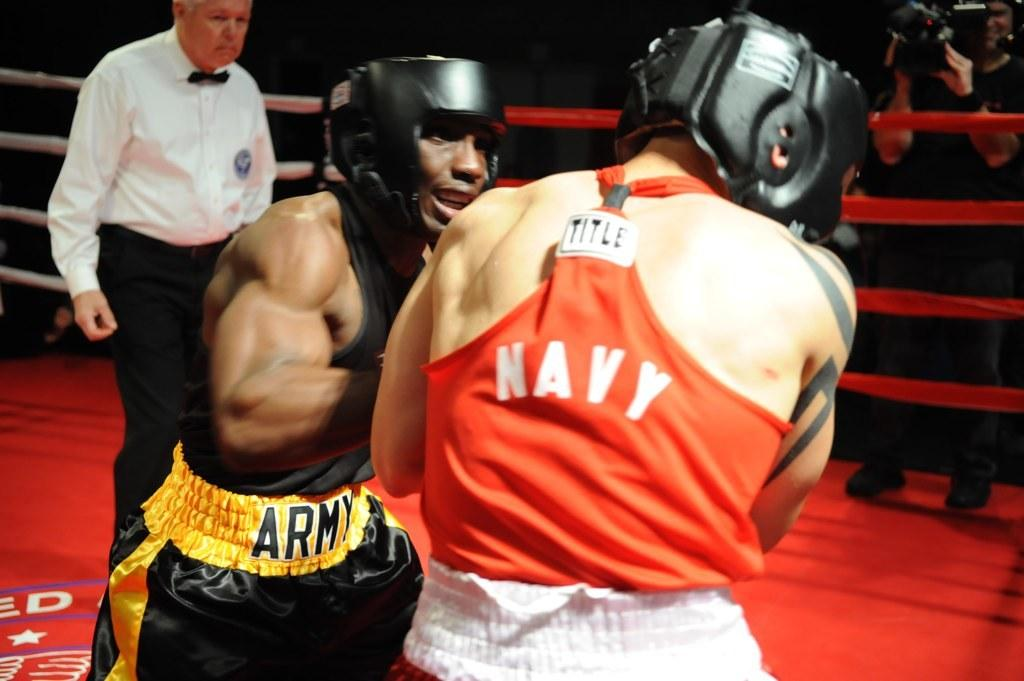Provide a one-sentence caption for the provided image. A man in black and gold Army shorts boxes with a man in an orange Navy shirt. 